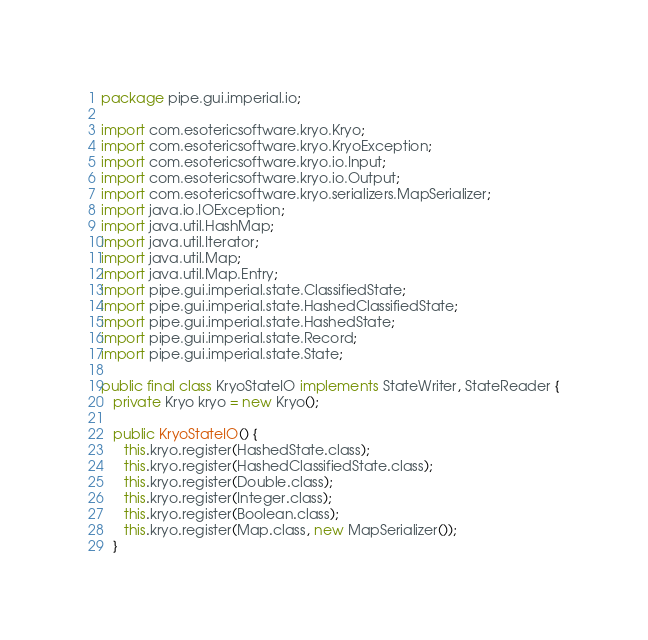<code> <loc_0><loc_0><loc_500><loc_500><_Java_>package pipe.gui.imperial.io;

import com.esotericsoftware.kryo.Kryo;
import com.esotericsoftware.kryo.KryoException;
import com.esotericsoftware.kryo.io.Input;
import com.esotericsoftware.kryo.io.Output;
import com.esotericsoftware.kryo.serializers.MapSerializer;
import java.io.IOException;
import java.util.HashMap;
import java.util.Iterator;
import java.util.Map;
import java.util.Map.Entry;
import pipe.gui.imperial.state.ClassifiedState;
import pipe.gui.imperial.state.HashedClassifiedState;
import pipe.gui.imperial.state.HashedState;
import pipe.gui.imperial.state.Record;
import pipe.gui.imperial.state.State;

public final class KryoStateIO implements StateWriter, StateReader {
   private Kryo kryo = new Kryo();

   public KryoStateIO() {
      this.kryo.register(HashedState.class);
      this.kryo.register(HashedClassifiedState.class);
      this.kryo.register(Double.class);
      this.kryo.register(Integer.class);
      this.kryo.register(Boolean.class);
      this.kryo.register(Map.class, new MapSerializer());
   }
</code> 